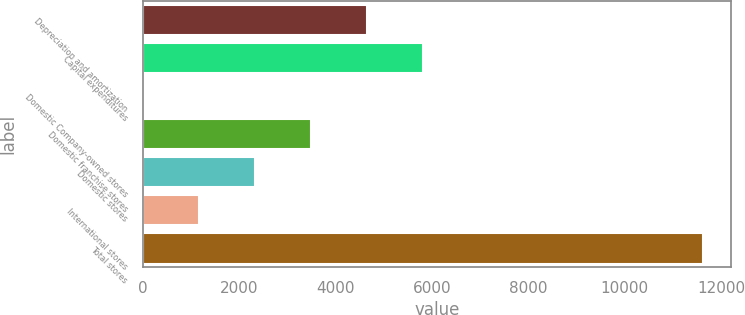Convert chart to OTSL. <chart><loc_0><loc_0><loc_500><loc_500><bar_chart><fcel>Depreciation and amortization<fcel>Capital expenditures<fcel>Domestic Company-owned stores<fcel>Domestic franchise stores<fcel>Domestic stores<fcel>International stores<fcel>Total stores<nl><fcel>4655.32<fcel>5817.6<fcel>6.2<fcel>3493.04<fcel>2330.76<fcel>1168.48<fcel>11629<nl></chart> 